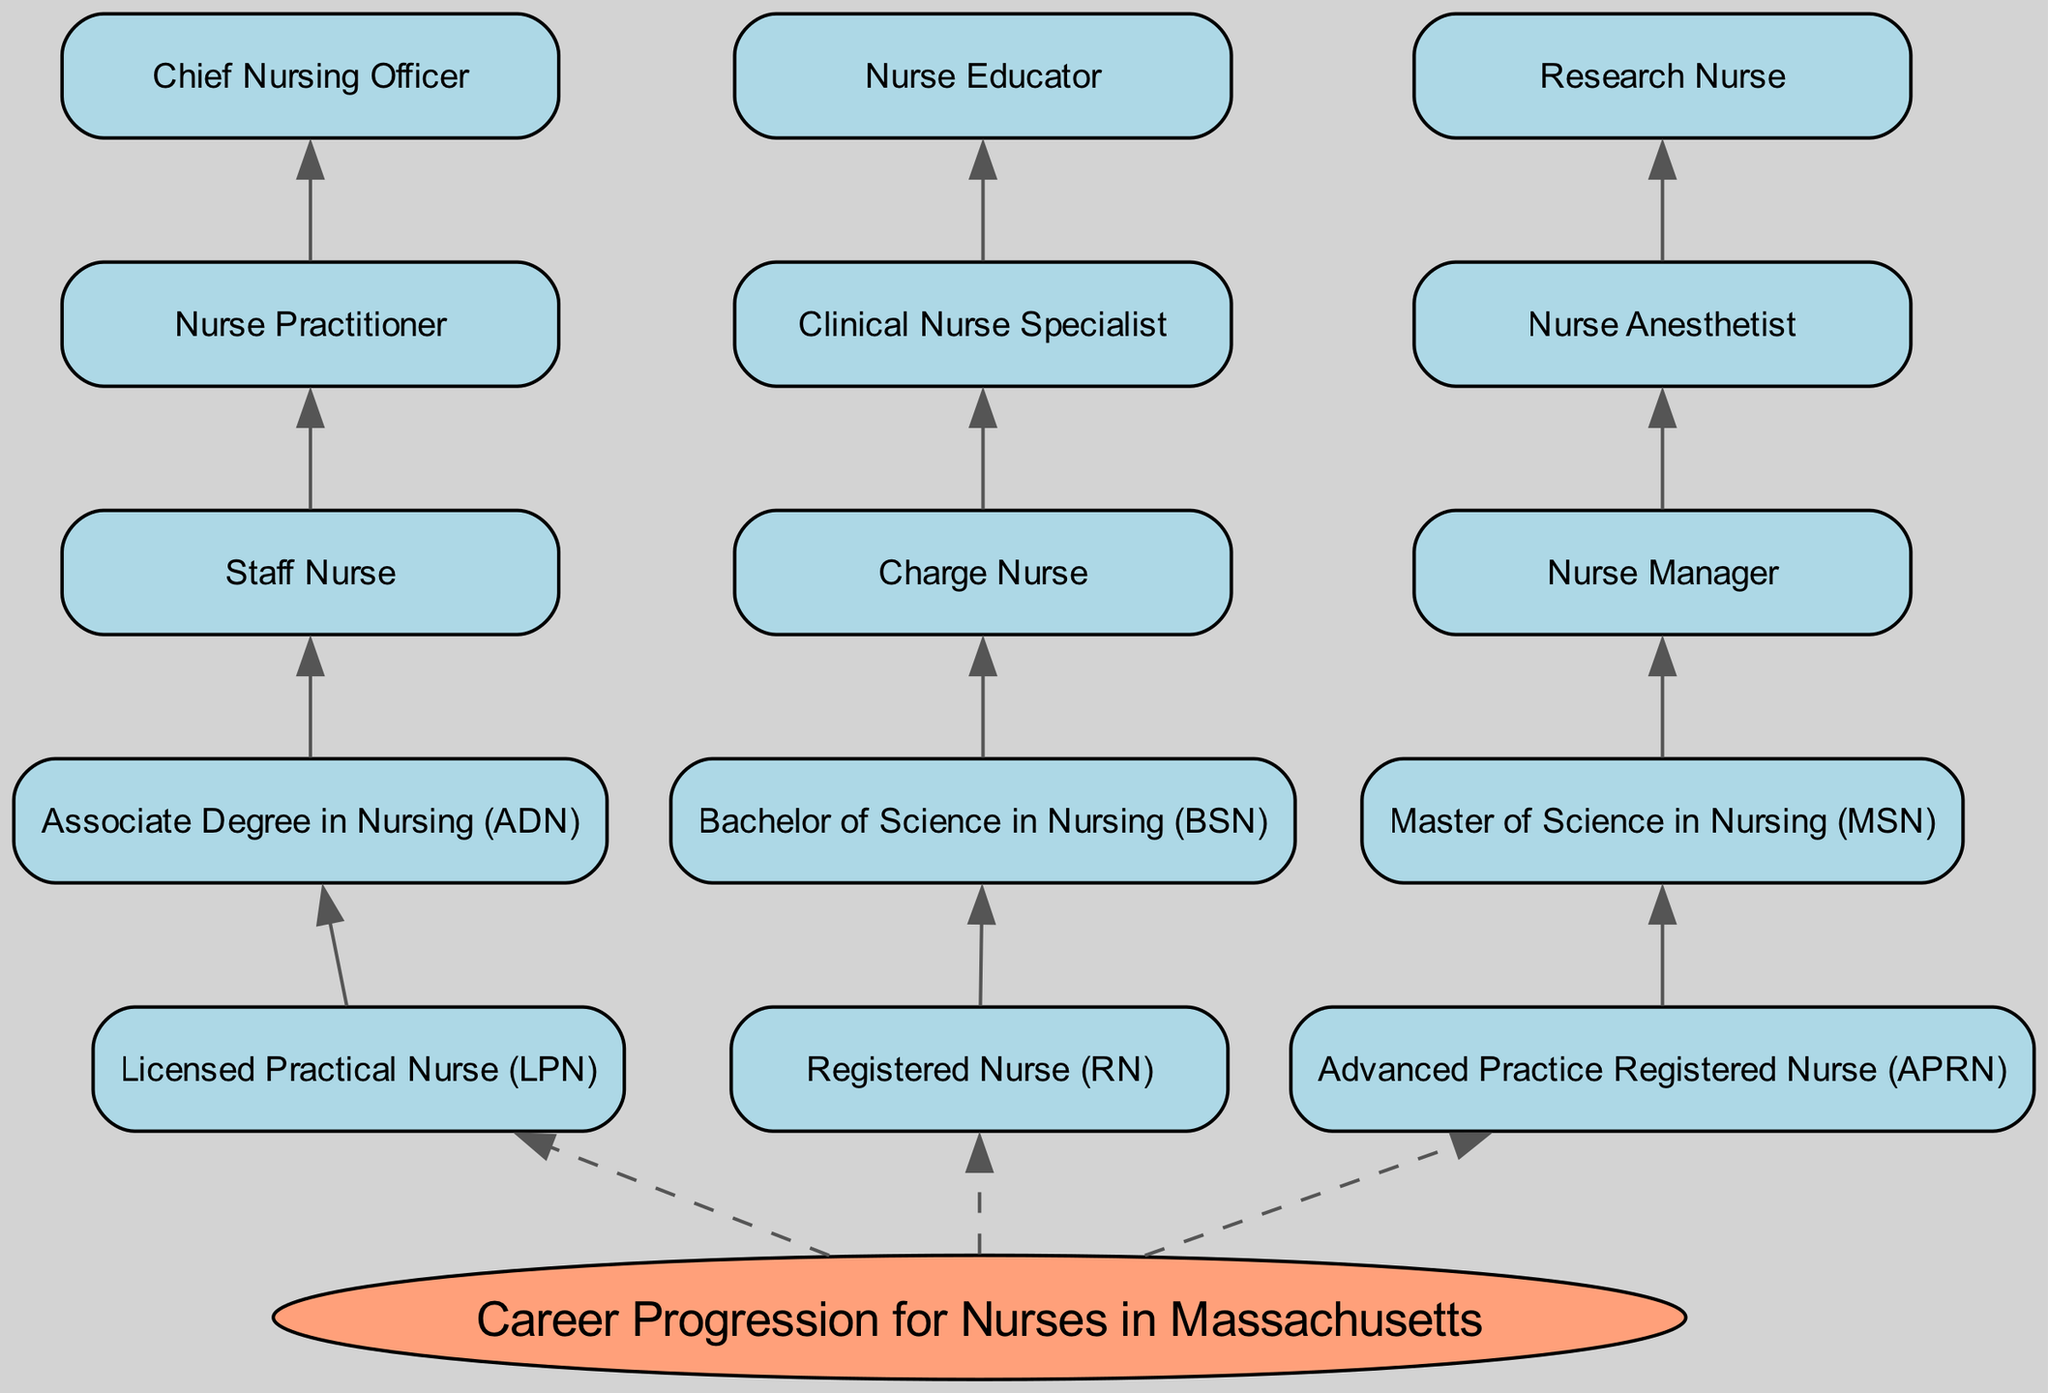What is the root node of the diagram? The root node is explicitly labeled as "Career Progression for Nurses in Massachusetts," which indicates the central theme of the diagram.
Answer: Career Progression for Nurses in Massachusetts How many levels are in the diagram? The diagram consists of five levels, as each level is numbered from 1 to 5, indicating the different stages in the career progression.
Answer: 5 What is the highest level node in the diagram? The highest level in the diagram corresponds to level 5, which has nodes including "Chief Nursing Officer," "Nurse Educator," and "Research Nurse." The 'highest' implies the final stage in career progression.
Answer: Chief Nursing Officer Which node leads to the "Nurse Manager"? The "Nurse Manager" node is reached from the "Master of Science in Nursing (MSN)" node, indicating a direct connection from an advanced degree to a leadership role in nursing.
Answer: Master of Science in Nursing (MSN) How many connections are there from level 1 to level 2 nodes? Level 1 has three nodes ("LPN," "RN," "APRN") with direct connections to level 2 nodes ("ADN," "BSN," "MSN"). Each level 1 node has one outgoing connection, resulting in three total connections.
Answer: 3 Which nursing role directly transitions from a "Charge Nurse"? The "Charge Nurse" node leads directly to the "Clinical Nurse Specialist," indicating that it is a relevant next step in career progression for someone in this position.
Answer: Clinical Nurse Specialist What is the connection between "Registered Nurse (RN)" and "Bachelor of Science in Nursing (BSN)"? The "Registered Nurse (RN)" node has a direct connection to the "Bachelor of Science in Nursing (BSN)" node, indicating that becoming an RN involves obtaining a BSN degree.
Answer: Bachelor of Science in Nursing (BSN) Is there a node that connects both "Nurse Practitioner" and "Chief Nursing Officer"? Yes, the "Nurse Practitioner" node connects directly to the "Chief Nursing Officer" node, indicating a progression from a practitioner role to an executive leadership role.
Answer: Yes Which node is the starting point for a "Staff Nurse"? The "Staff Nurse" node is reached from the "Associate Degree in Nursing (ADN)" node, indicating that this is where one typically begins a career as a staff nurse.
Answer: Associate Degree in Nursing (ADN) 